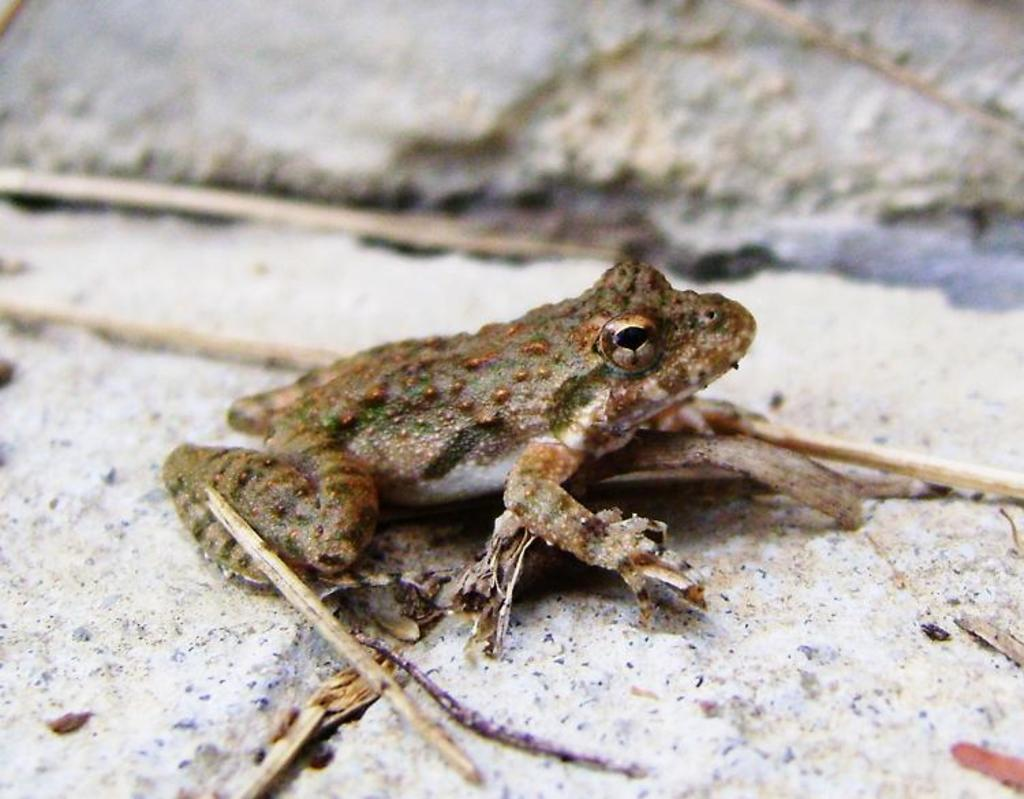What type of animal is in the foreground of the image? There is a frog on the surface in the foreground of the image. What other objects can be seen in the image? There are a few sticks visible in the image. What type of lock is the frog using to secure its belongings in the image? There is no lock or belongings present in the image; it features a frog and some sticks. Can you tell me how many horses are visible in the image? There are no horses present in the image. 